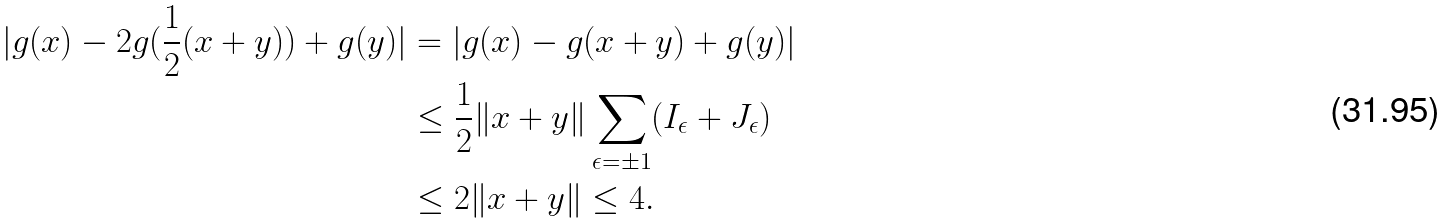Convert formula to latex. <formula><loc_0><loc_0><loc_500><loc_500>| g ( x ) - 2 g ( \frac { 1 } { 2 } ( x + y ) ) + g ( y ) | & = | g ( x ) - g ( x + y ) + g ( y ) | \\ & \leq \frac { 1 } { 2 } \| x + y \| \sum _ { \epsilon = \pm 1 } ( I _ { \epsilon } + J _ { \epsilon } ) \\ & \leq 2 \| x + y \| \leq 4 .</formula> 